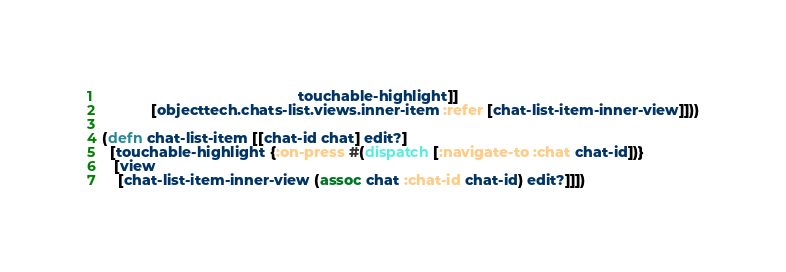<code> <loc_0><loc_0><loc_500><loc_500><_Clojure_>                                                touchable-highlight]]
            [objecttech.chats-list.views.inner-item :refer [chat-list-item-inner-view]]))

(defn chat-list-item [[chat-id chat] edit?]
  [touchable-highlight {:on-press #(dispatch [:navigate-to :chat chat-id])}
   [view
    [chat-list-item-inner-view (assoc chat :chat-id chat-id) edit?]]])
</code> 